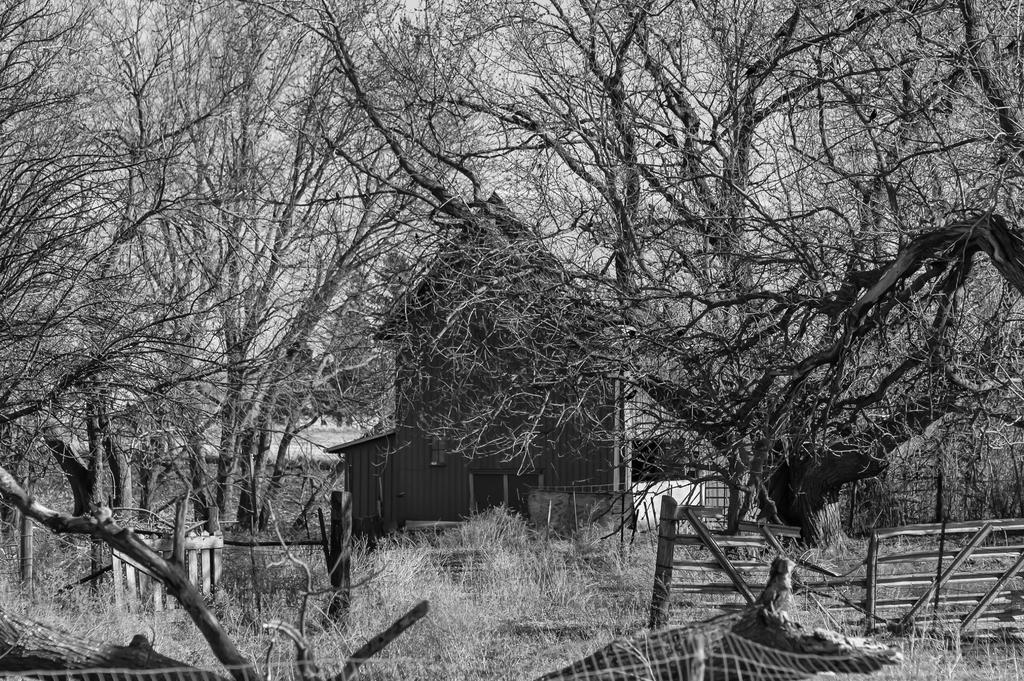Describe this image in one or two sentences. It looks like a black and white picture. We can see a wooden fence, branches, trees and a house. Behind the house there is a sky. 